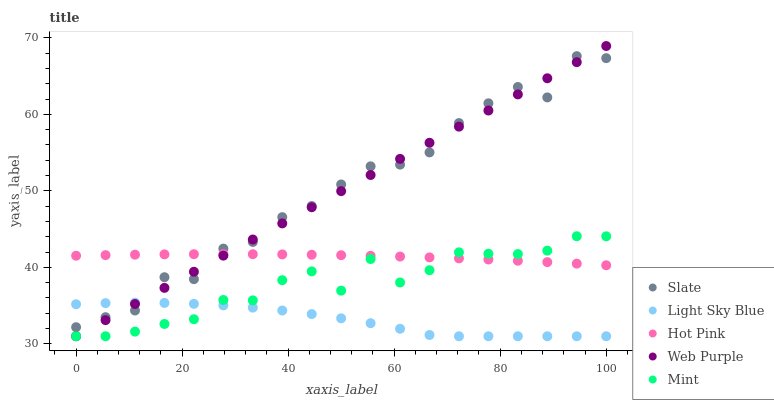Does Light Sky Blue have the minimum area under the curve?
Answer yes or no. Yes. Does Slate have the maximum area under the curve?
Answer yes or no. Yes. Does Mint have the minimum area under the curve?
Answer yes or no. No. Does Mint have the maximum area under the curve?
Answer yes or no. No. Is Web Purple the smoothest?
Answer yes or no. Yes. Is Slate the roughest?
Answer yes or no. Yes. Is Light Sky Blue the smoothest?
Answer yes or no. No. Is Light Sky Blue the roughest?
Answer yes or no. No. Does Light Sky Blue have the lowest value?
Answer yes or no. Yes. Does Hot Pink have the lowest value?
Answer yes or no. No. Does Web Purple have the highest value?
Answer yes or no. Yes. Does Mint have the highest value?
Answer yes or no. No. Is Mint less than Slate?
Answer yes or no. Yes. Is Hot Pink greater than Light Sky Blue?
Answer yes or no. Yes. Does Slate intersect Web Purple?
Answer yes or no. Yes. Is Slate less than Web Purple?
Answer yes or no. No. Is Slate greater than Web Purple?
Answer yes or no. No. Does Mint intersect Slate?
Answer yes or no. No. 